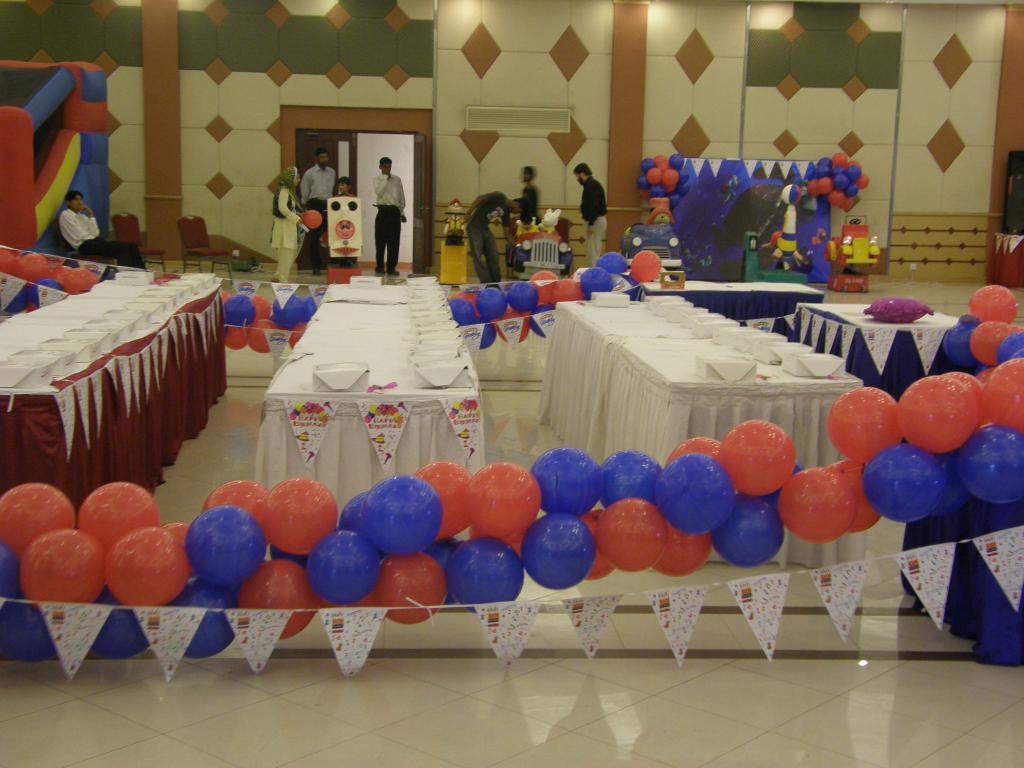In one or two sentences, can you explain what this image depicts? Here in this picture we can see number of tables present on the floor and we can also see number of boxes on it and beside that on either side we can see balloons and decoration papers hanging and in the far we can see number of people standing on the floor and on the left side we can see a person sitting on chair and we can also see other number of chairs present and we can see there also some part of place is decorated with balloons. 